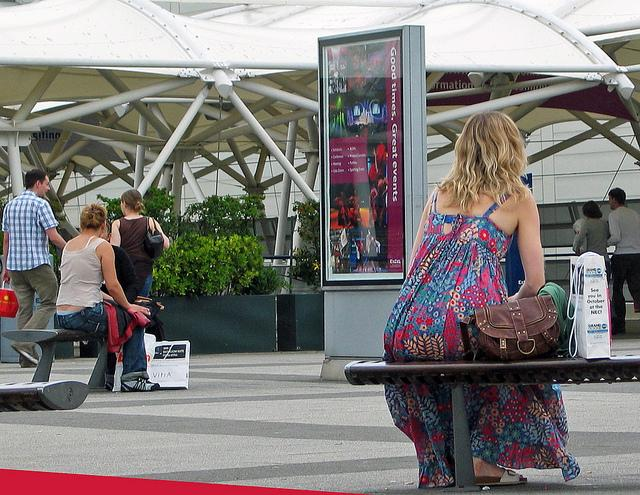What color is the leather of the woman's purse who is sitting on the bench to the right? Please explain your reasoning. tan. The woman that is sitting on the bench to the right has a purse made of tan leather. 